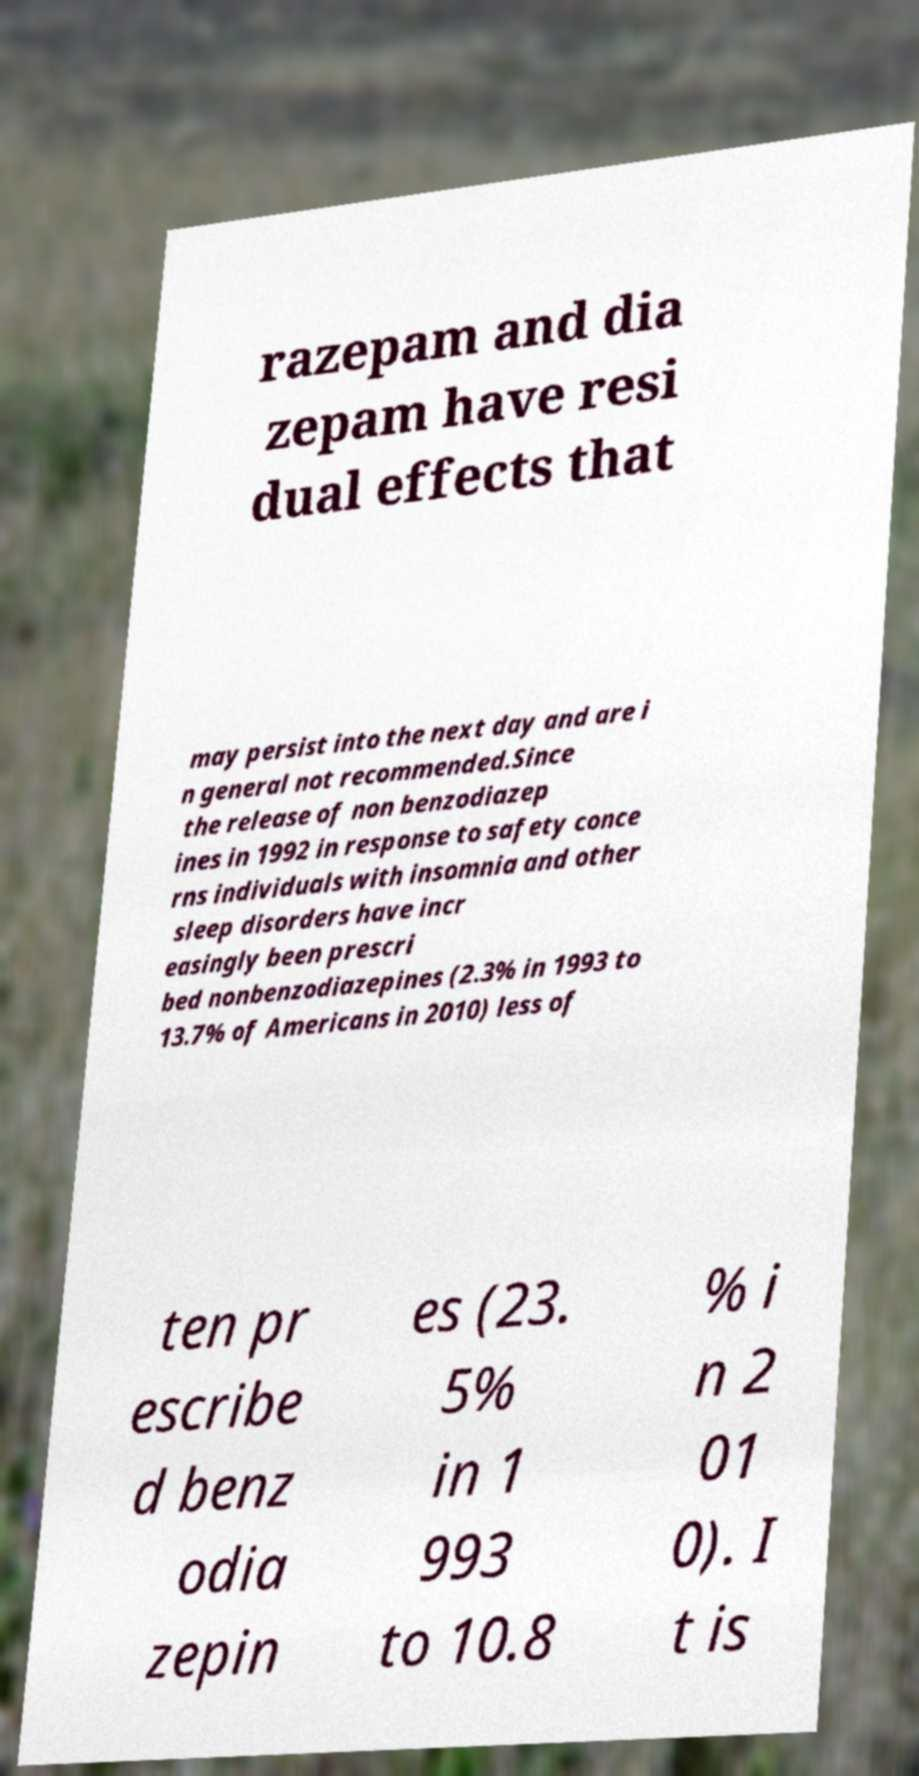Can you accurately transcribe the text from the provided image for me? razepam and dia zepam have resi dual effects that may persist into the next day and are i n general not recommended.Since the release of non benzodiazep ines in 1992 in response to safety conce rns individuals with insomnia and other sleep disorders have incr easingly been prescri bed nonbenzodiazepines (2.3% in 1993 to 13.7% of Americans in 2010) less of ten pr escribe d benz odia zepin es (23. 5% in 1 993 to 10.8 % i n 2 01 0). I t is 